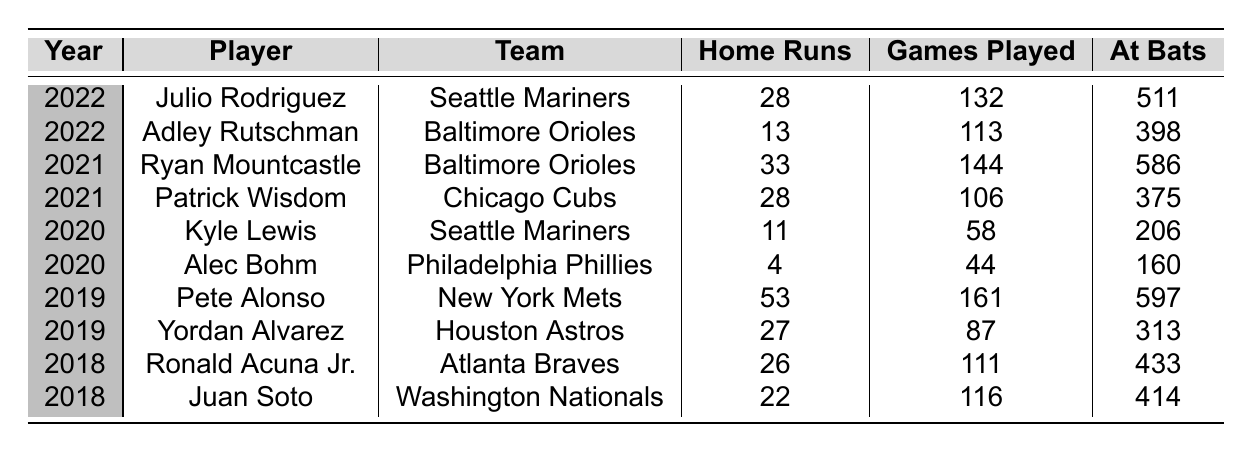What is the highest number of home runs hit by a rookie player in the last five years? The table shows the home run statistics for rookie players. The maximum value in the "Home Runs" column is 53, which belongs to Pete Alonso in 2019.
Answer: 53 Which player hit the most home runs in the year 2021? By looking at the data for 2021, Ryan Mountcastle had the highest home runs at 33, compared to Patrick Wisdom who hit 28.
Answer: Ryan Mountcastle In which year did Kyle Lewis play, and how many home runs did he hit? The table indicates that Kyle Lewis played in 2020 and hit 11 home runs.
Answer: 2020, 11 What is the total number of home runs hit by rookie players in the year 2022? To find the total for 2022, add the home runs from Julio Rodriguez (28) and Adley Rutschman (13), which equals 28 + 13 = 41.
Answer: 41 How many games did Pete Alonso play in his rookie year? The table lists that Pete Alonso played 161 games in 2019.
Answer: 161 Did Yordan Alvarez hit more or fewer home runs than Kyle Lewis? Yordan Alvarez hit 27 home runs, while Kyle Lewis hit only 11. Since 27 is greater than 11, the answer is more.
Answer: More What is the average number of home runs for the players in 2018? For 2018, Ronald Acuna Jr. hit 26 and Juan Soto hit 22, giving a total of 26 + 22 = 48. There are 2 players, so the average is 48 / 2 = 24.
Answer: 24 Which rookies from the Baltimore Orioles appear in the data and what were their home run totals? Two players from the Baltimore Orioles appear: Adley Rutschman with 13 home runs and Ryan Mountcastle with 33 home runs.
Answer: Adley Rutschman (13), Ryan Mountcastle (33) How does the home run total of Alec Bohm compare to that of Juan Soto? Alec Bohm hit 4 home runs in 2020 while Juan Soto hit 22 in 2018. Since 22 is greater than 4, Juan Soto hit more.
Answer: Juan Soto hit more In what year did players collectively hit the least number of home runs, based on the data provided? To determine this, examine each year's total: 2018 (48), 2019 (80), 2020 (15), 2021 (61), and 2022 (41). The lowest total is for 2020 with 15 home runs.
Answer: 2020 